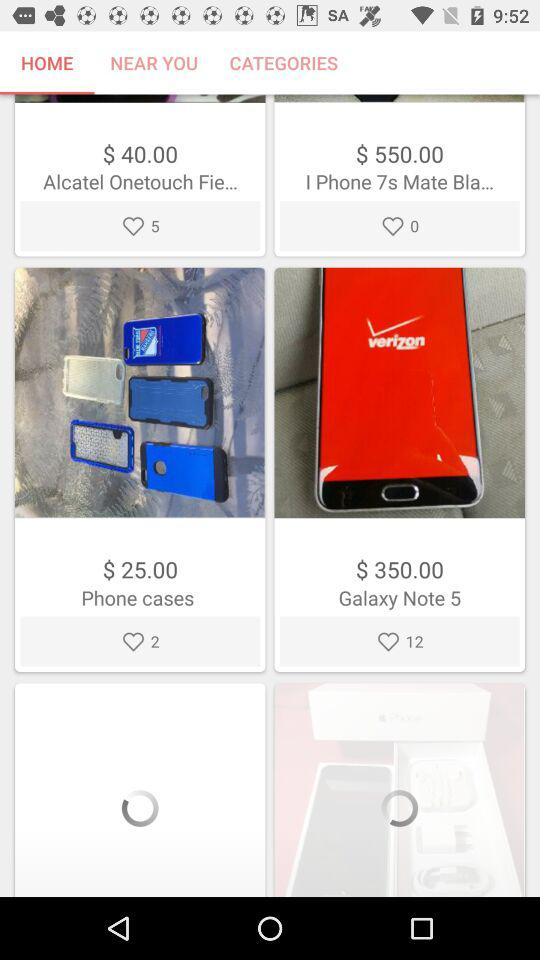How many likes does "Phone cases" have? "Phone cases" have 2 likes. 